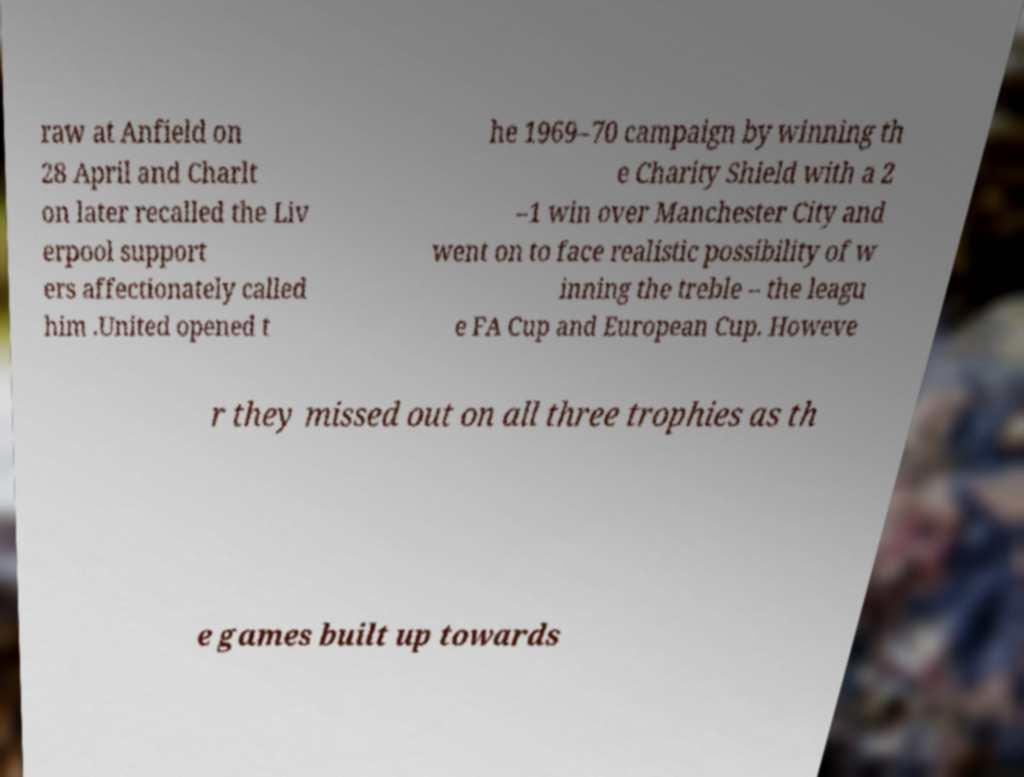Can you accurately transcribe the text from the provided image for me? raw at Anfield on 28 April and Charlt on later recalled the Liv erpool support ers affectionately called him .United opened t he 1969–70 campaign by winning th e Charity Shield with a 2 –1 win over Manchester City and went on to face realistic possibility of w inning the treble – the leagu e FA Cup and European Cup. Howeve r they missed out on all three trophies as th e games built up towards 